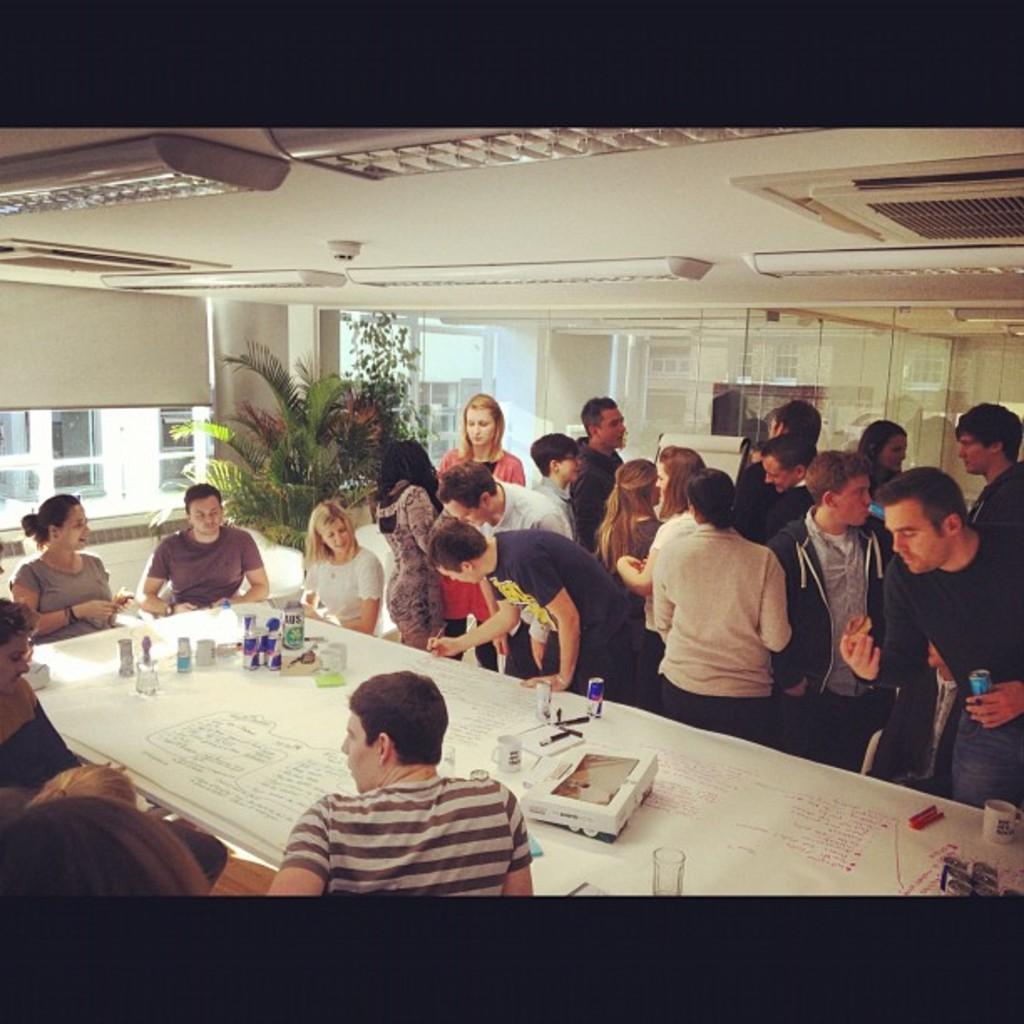Can you describe this image briefly? On the right there is a group of person who are standing near to a table. On the table there is a box, can, cup and a paper. On the bottom there is a boy who is wearing a striped t-shirt. On the center there is a plant. On the left side we can see a window. 